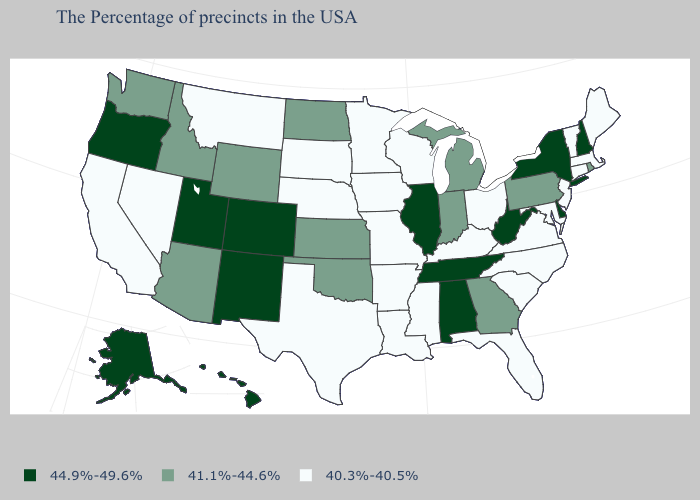Does the map have missing data?
Write a very short answer. No. What is the highest value in states that border California?
Give a very brief answer. 44.9%-49.6%. How many symbols are there in the legend?
Quick response, please. 3. How many symbols are there in the legend?
Keep it brief. 3. What is the value of California?
Keep it brief. 40.3%-40.5%. What is the value of Kansas?
Give a very brief answer. 41.1%-44.6%. What is the value of Delaware?
Short answer required. 44.9%-49.6%. Does Rhode Island have a higher value than Vermont?
Answer briefly. Yes. What is the value of Tennessee?
Give a very brief answer. 44.9%-49.6%. Which states have the highest value in the USA?
Quick response, please. New Hampshire, New York, Delaware, West Virginia, Alabama, Tennessee, Illinois, Colorado, New Mexico, Utah, Oregon, Alaska, Hawaii. Does Alabama have a higher value than Florida?
Give a very brief answer. Yes. Does the first symbol in the legend represent the smallest category?
Quick response, please. No. What is the value of Mississippi?
Short answer required. 40.3%-40.5%. Name the states that have a value in the range 44.9%-49.6%?
Quick response, please. New Hampshire, New York, Delaware, West Virginia, Alabama, Tennessee, Illinois, Colorado, New Mexico, Utah, Oregon, Alaska, Hawaii. 